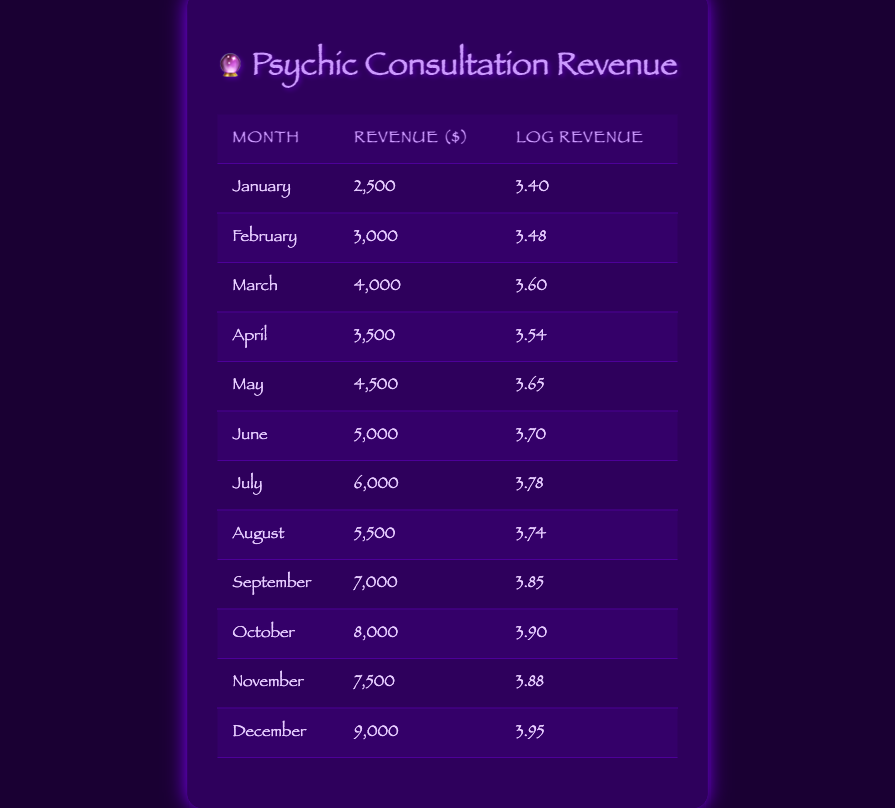What was the revenue in March? The table lists the revenue for each month. For March, the revenue is specifically noted as 4000.
Answer: 4000 Which month had the highest revenue, and what was that amount? The table outlines revenues for all months. Scanning through, December shows the highest revenue at 9000.
Answer: December, 9000 What is the average revenue over the year? To find the average revenue, sum all monthly revenues: (2500 + 3000 + 4000 + 3500 + 4500 + 5000 + 6000 + 5500 + 7000 + 8000 + 7500 + 9000) = 57000. Then divide by 12 months: 57000 / 12 = 4750.
Answer: 4750 Did the revenue in June exceed 6000? Looking closely at the table, June's revenue is 5000, which is less than 6000.
Answer: No What is the difference between the revenue in October and April? From the table, October has a revenue of 8000 and April has a revenue of 3500. The difference is calculated as 8000 - 3500 = 4500.
Answer: 4500 Which month had a revenue greater than 6000 and was not December? By reviewing the table, the months with revenues over 6000 are July (6000), September (7000), and October (8000). The answer excludes December.
Answer: July, September, October What was the total revenue for the first half of the year (January to June)? First, we add the revenues for those months: January (2500) + February (3000) + March (4000) + April (3500) + May (4500) + June (5000) = 22500.
Answer: 22500 Is the log revenue for November higher than that for February? The log revenue for November is noted as 3.88 and for February as 3.48 in the table. Since 3.88 is greater than 3.48, the statement is true.
Answer: Yes What is the ratio of the revenue in July to that in January? The revenue for July is 6000 and for January is 2500. The ratio is calculated as 6000 / 2500 = 2.4.
Answer: 2.4 